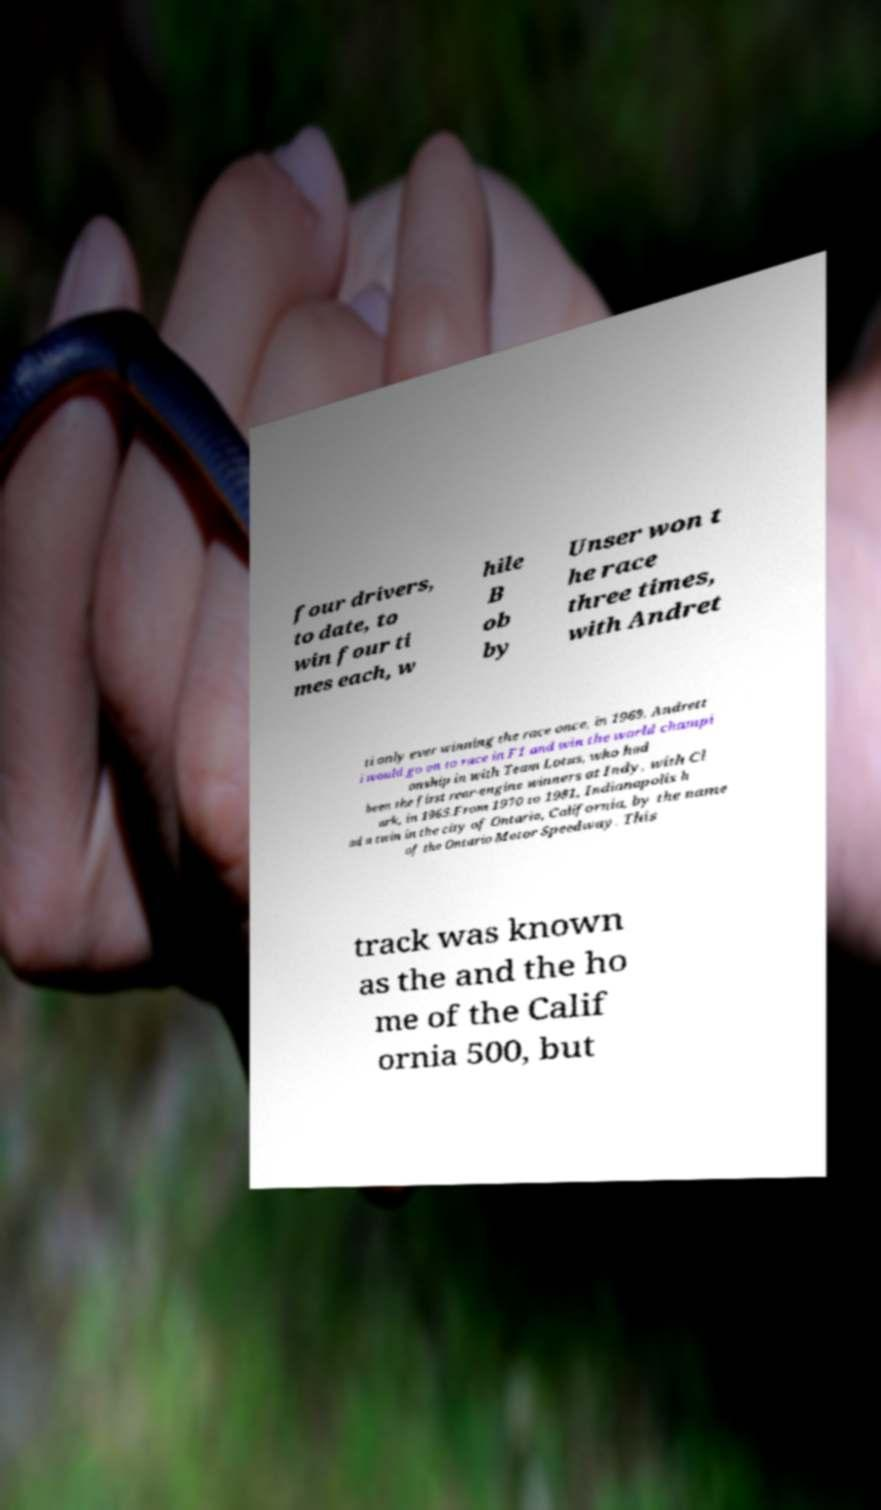Please read and relay the text visible in this image. What does it say? four drivers, to date, to win four ti mes each, w hile B ob by Unser won t he race three times, with Andret ti only ever winning the race once, in 1969. Andrett i would go on to race in F1 and win the world champi onship in with Team Lotus, who had been the first rear-engine winners at Indy, with Cl ark, in 1965.From 1970 to 1981, Indianapolis h ad a twin in the city of Ontario, California, by the name of the Ontario Motor Speedway. This track was known as the and the ho me of the Calif ornia 500, but 